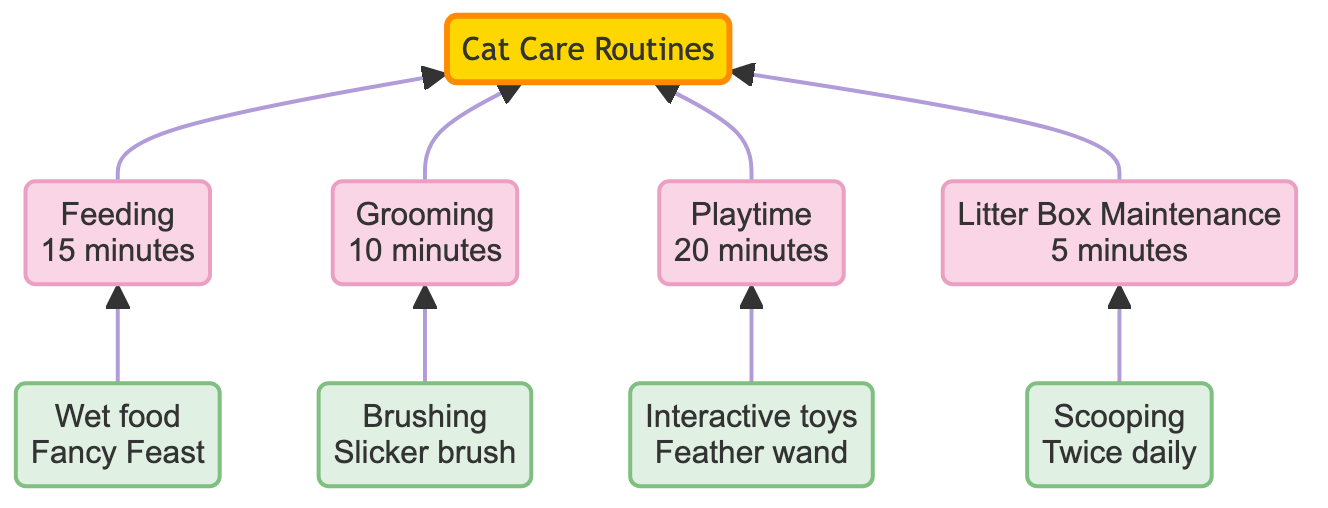What activity has the longest time estimate? To determine which activity takes the longest, I can compare the time estimates provided for each activity: Feeding takes 15 minutes, Grooming takes 10 minutes, Playtime takes 20 minutes, and Litter Box Maintenance takes 5 minutes. The longest time is associated with Playtime.
Answer: Playtime How many main activities are listed in the diagram? The diagram displays four main activities: Feeding, Grooming, Playtime, and Litter Box Maintenance. Counting these gives me a total of four main activities.
Answer: 4 What is the specific toy used in playtime? The playtime activity shows "Interactive toys" and specifies "Feather wand" as the specific toy used. By looking directly at the detail for playtime, I obtain the answer.
Answer: Feather wand How often is litter box maintenance performed? The detail associated with Litter Box Maintenance specifies that it occurs "Twice daily." This indicates the frequency of this particular activity.
Answer: Twice daily What method is used for grooming? The grooming activity describes the method as "Brushing," and further specifies the tool used as a "Slicker brush." By observing the details under the grooming activity, I can identify the method.
Answer: Brushing Which activity is associated with the least time? Comparing all the time estimates, I can see that Litter Box Maintenance takes 5 minutes, which is less than Feeding, Grooming, and Playtime. This makes Litter Box Maintenance the activity with the least time associated.
Answer: Litter Box Maintenance Which activity does not involve a specific brand? Looking at the activities, the grooming routine does not mention any specific brand. Feeding specifies "Fancy Feast," and Playtime states the "Feather wand," but the Grooming method has no brand attached.
Answer: Grooming What type of food is fed to the cat? The feeding activity specifies that the type of food provided is "Wet food." I can identify this by directly looking at the details under the feeding routine.
Answer: Wet food 